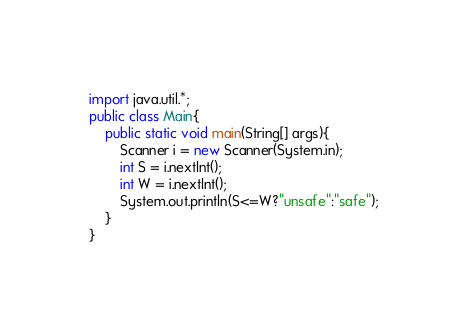Convert code to text. <code><loc_0><loc_0><loc_500><loc_500><_Java_>import java.util.*;
public class Main{
	public static void main(String[] args){
      	Scanner i = new Scanner(System.in);
		int S = i.nextInt();
		int W = i.nextInt();
  		System.out.println(S<=W?"unsafe":"safe");
	}
}</code> 